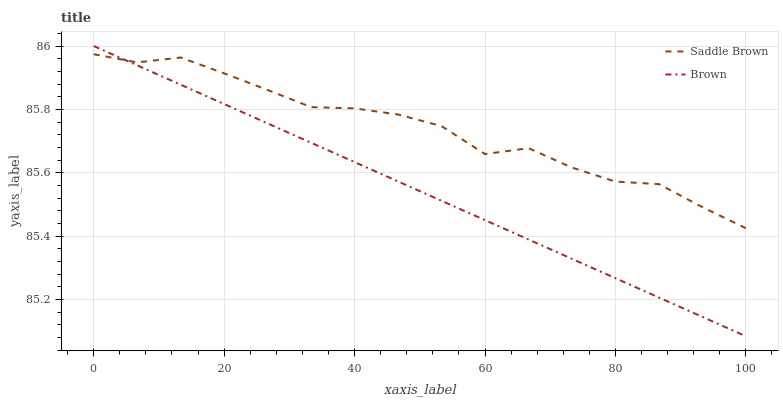Does Saddle Brown have the minimum area under the curve?
Answer yes or no. No. Is Saddle Brown the smoothest?
Answer yes or no. No. Does Saddle Brown have the lowest value?
Answer yes or no. No. Does Saddle Brown have the highest value?
Answer yes or no. No. 